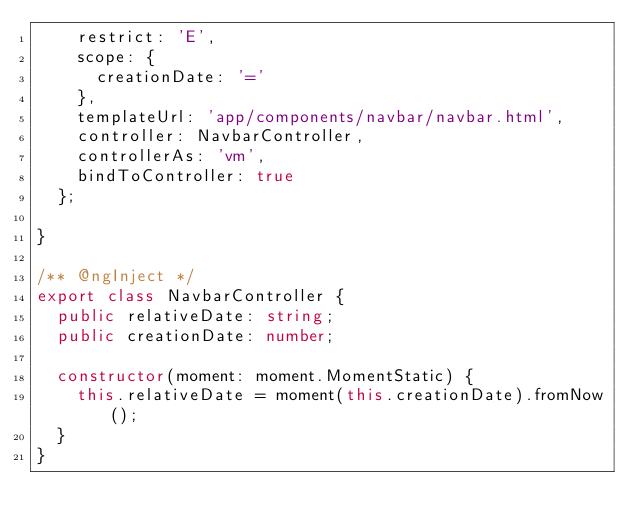<code> <loc_0><loc_0><loc_500><loc_500><_TypeScript_>    restrict: 'E',
    scope: {
      creationDate: '='
    },
    templateUrl: 'app/components/navbar/navbar.html',
    controller: NavbarController,
    controllerAs: 'vm',
    bindToController: true
  };

}

/** @ngInject */
export class NavbarController {
  public relativeDate: string;
  public creationDate: number;

  constructor(moment: moment.MomentStatic) {
    this.relativeDate = moment(this.creationDate).fromNow();
  }
}
</code> 